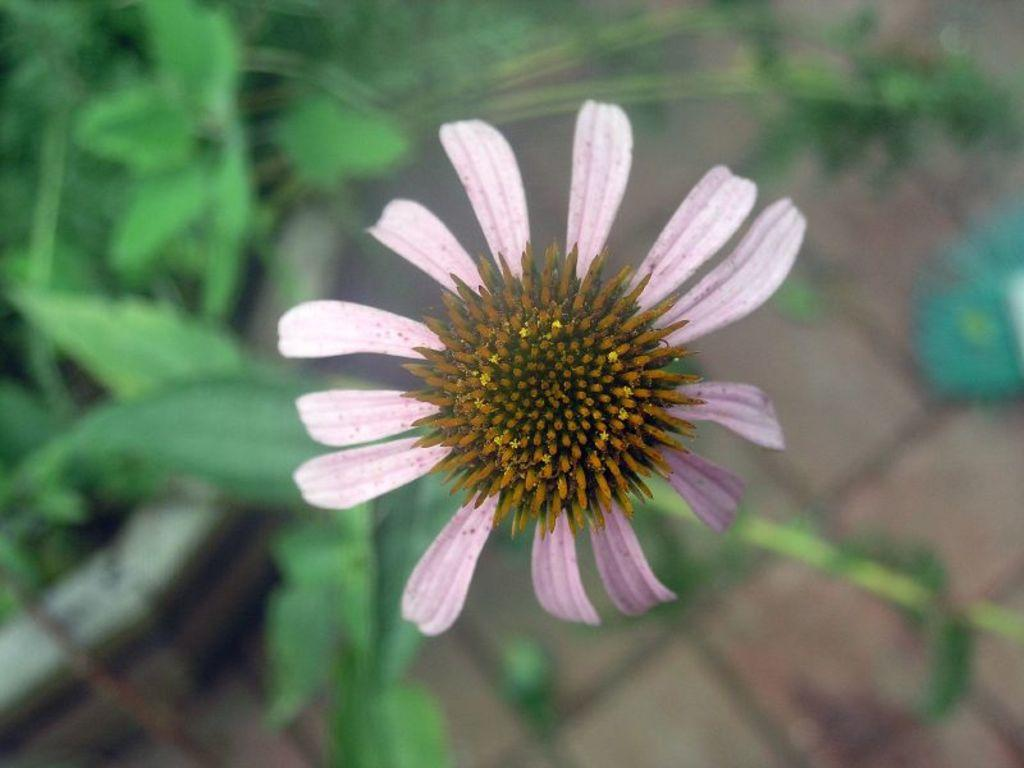What is the main subject in the center of the image? There is a flower in the center of the image. What else can be seen at the bottom of the image? There are plants at the bottom of the image. Are there any other plant-related elements visible in the image? Yes, leaves are visible in the image. What is the tendency of the ear in the image? There is no ear present in the image, so it is not possible to determine any tendencies. 